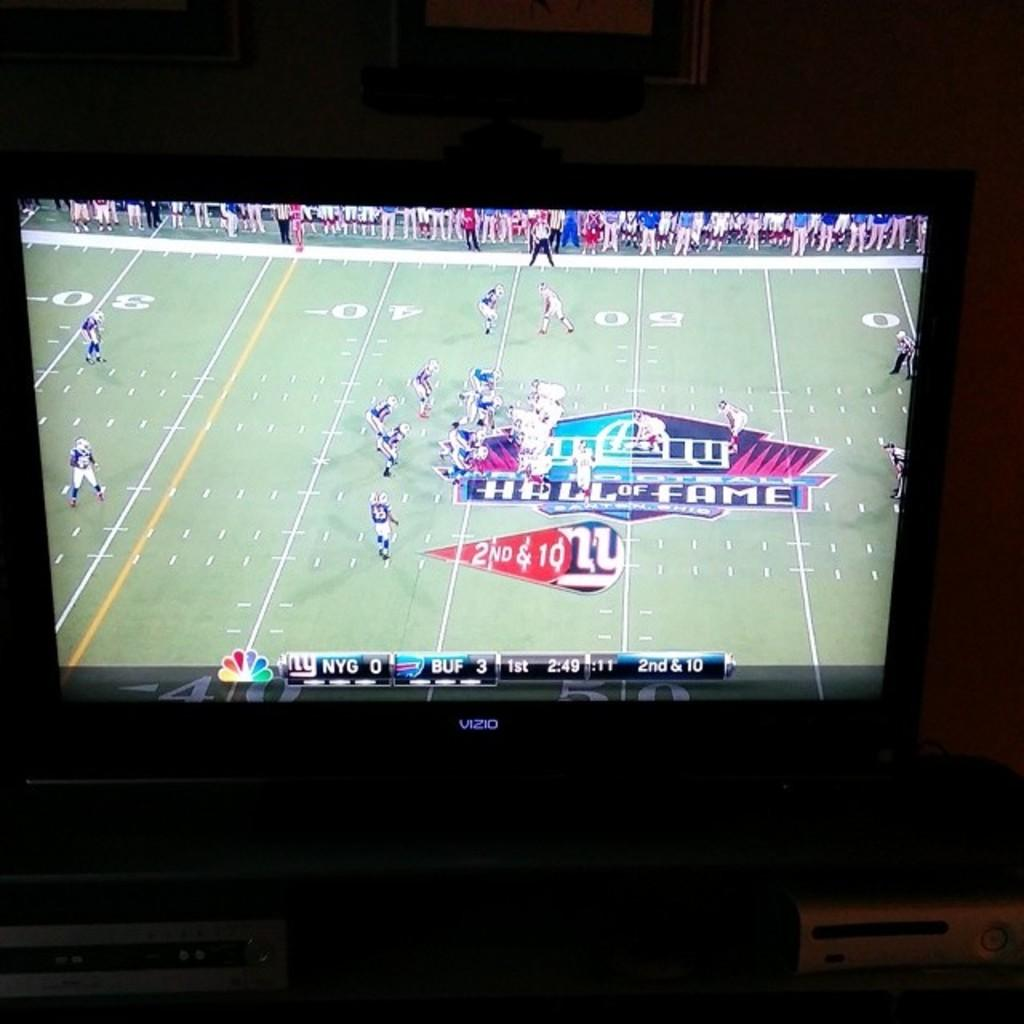<image>
Give a short and clear explanation of the subsequent image. A Vizio TV with a football game on it. 